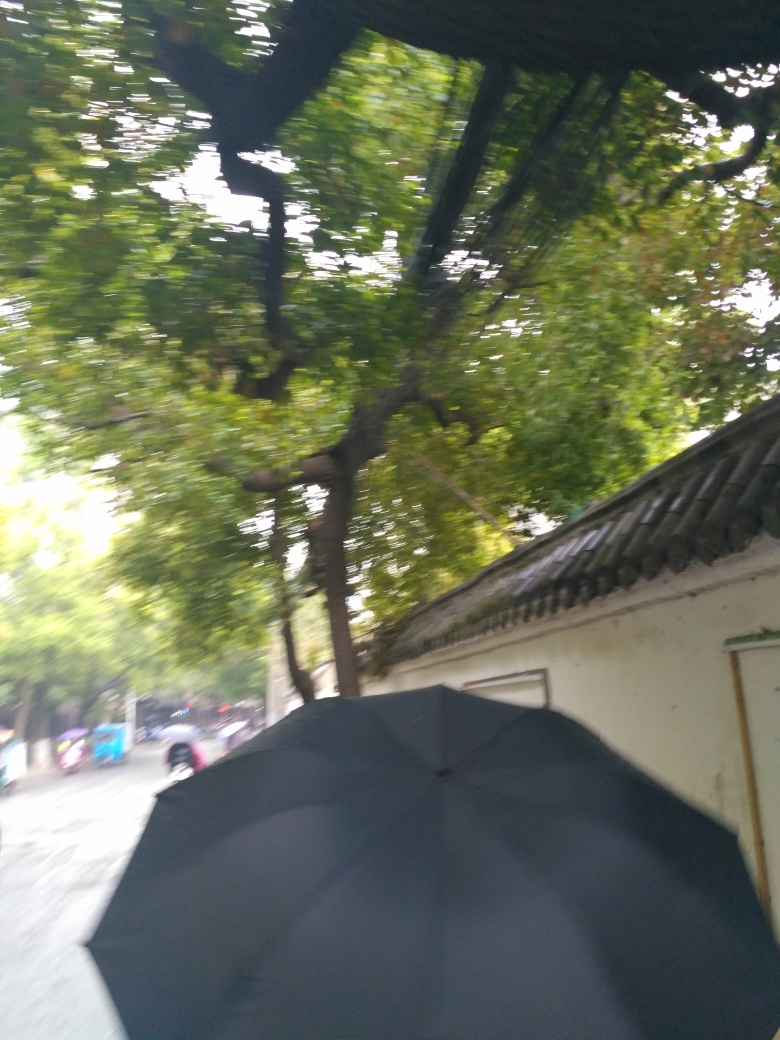Can you describe the setting of the photograph? The setting appears to be an urban environment with traditional-style buildings, possibly in a historical district. The lush greenery suggests a well-tended area, possibly near a park or garden. Is there anything unique about the architecture? The roof visible in the photograph has distinctive tiles that are characteristic of certain traditional architectural styles, which could provide clues to the specific cultural or historical context of the location. 